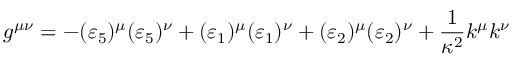Convert formula to latex. <formula><loc_0><loc_0><loc_500><loc_500>g ^ { \mu \nu } = - ( \varepsilon _ { 5 } ) ^ { \mu } ( \varepsilon _ { 5 } ) ^ { \nu } + ( \varepsilon _ { 1 } ) ^ { \mu } ( \varepsilon _ { 1 } ) ^ { \nu } + ( \varepsilon _ { 2 } ) ^ { \mu } ( \varepsilon _ { 2 } ) ^ { \nu } + \frac { 1 } { \kappa ^ { 2 } } k ^ { \mu } k ^ { \nu }</formula> 